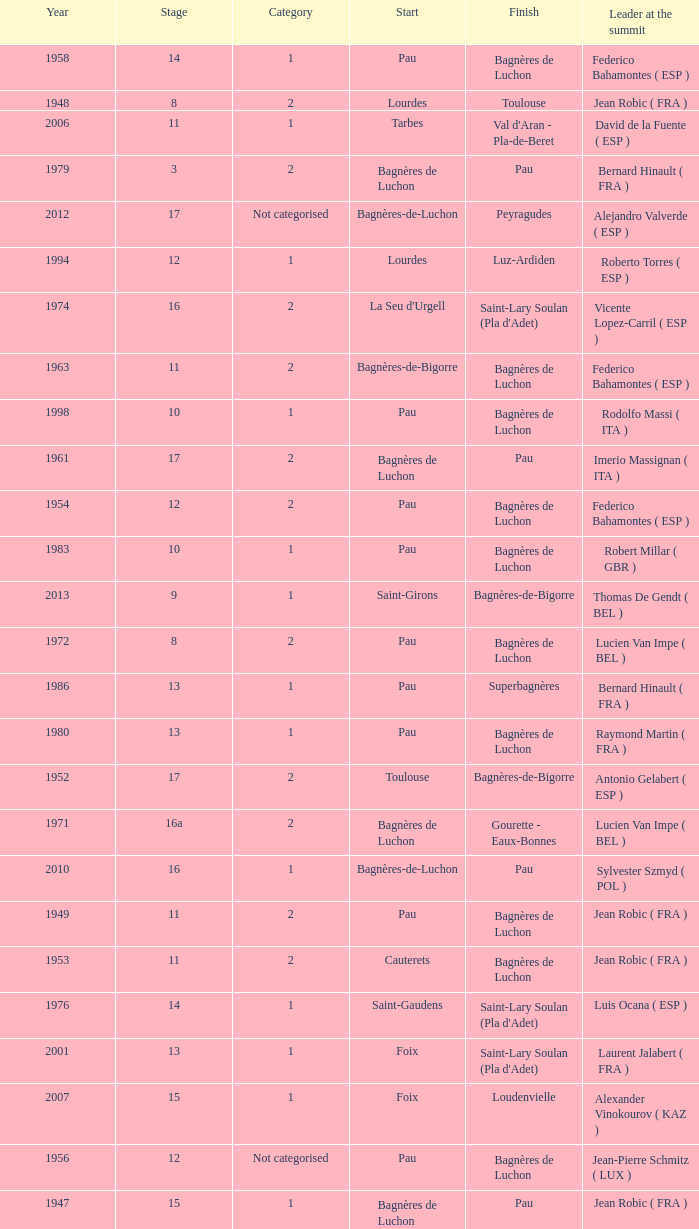What stage has a start of saint-girons in 1988? 15.0. Can you give me this table as a dict? {'header': ['Year', 'Stage', 'Category', 'Start', 'Finish', 'Leader at the summit'], 'rows': [['1958', '14', '1', 'Pau', 'Bagnères de Luchon', 'Federico Bahamontes ( ESP )'], ['1948', '8', '2', 'Lourdes', 'Toulouse', 'Jean Robic ( FRA )'], ['2006', '11', '1', 'Tarbes', "Val d'Aran - Pla-de-Beret", 'David de la Fuente ( ESP )'], ['1979', '3', '2', 'Bagnères de Luchon', 'Pau', 'Bernard Hinault ( FRA )'], ['2012', '17', 'Not categorised', 'Bagnères-de-Luchon', 'Peyragudes', 'Alejandro Valverde ( ESP )'], ['1994', '12', '1', 'Lourdes', 'Luz-Ardiden', 'Roberto Torres ( ESP )'], ['1974', '16', '2', "La Seu d'Urgell", "Saint-Lary Soulan (Pla d'Adet)", 'Vicente Lopez-Carril ( ESP )'], ['1963', '11', '2', 'Bagnères-de-Bigorre', 'Bagnères de Luchon', 'Federico Bahamontes ( ESP )'], ['1998', '10', '1', 'Pau', 'Bagnères de Luchon', 'Rodolfo Massi ( ITA )'], ['1961', '17', '2', 'Bagnères de Luchon', 'Pau', 'Imerio Massignan ( ITA )'], ['1954', '12', '2', 'Pau', 'Bagnères de Luchon', 'Federico Bahamontes ( ESP )'], ['1983', '10', '1', 'Pau', 'Bagnères de Luchon', 'Robert Millar ( GBR )'], ['2013', '9', '1', 'Saint-Girons', 'Bagnères-de-Bigorre', 'Thomas De Gendt ( BEL )'], ['1972', '8', '2', 'Pau', 'Bagnères de Luchon', 'Lucien Van Impe ( BEL )'], ['1986', '13', '1', 'Pau', 'Superbagnères', 'Bernard Hinault ( FRA )'], ['1980', '13', '1', 'Pau', 'Bagnères de Luchon', 'Raymond Martin ( FRA )'], ['1952', '17', '2', 'Toulouse', 'Bagnères-de-Bigorre', 'Antonio Gelabert ( ESP )'], ['1971', '16a', '2', 'Bagnères de Luchon', 'Gourette - Eaux-Bonnes', 'Lucien Van Impe ( BEL )'], ['2010', '16', '1', 'Bagnères-de-Luchon', 'Pau', 'Sylvester Szmyd ( POL )'], ['1949', '11', '2', 'Pau', 'Bagnères de Luchon', 'Jean Robic ( FRA )'], ['1953', '11', '2', 'Cauterets', 'Bagnères de Luchon', 'Jean Robic ( FRA )'], ['1976', '14', '1', 'Saint-Gaudens', "Saint-Lary Soulan (Pla d'Adet)", 'Luis Ocana ( ESP )'], ['2001', '13', '1', 'Foix', "Saint-Lary Soulan (Pla d'Adet)", 'Laurent Jalabert ( FRA )'], ['2007', '15', '1', 'Foix', 'Loudenvielle', 'Alexander Vinokourov ( KAZ )'], ['1956', '12', 'Not categorised', 'Pau', 'Bagnères de Luchon', 'Jean-Pierre Schmitz ( LUX )'], ['1947', '15', '1', 'Bagnères de Luchon', 'Pau', 'Jean Robic ( FRA )'], ['1969', '17', '2', 'La Mongie', 'Mourenx', 'Joaquim Galera ( ESP )'], ['2012', '16', '1', 'Pau', 'Bagnères-de-Luchon', 'Thomas Voeckler ( FRA )'], ['1951', '14', '2', 'Tarbes', 'Bagnères de Luchon', 'Fausto Coppi ( ITA )'], ['1962', '12', '2', 'Pau', 'Saint-Gaudens', 'Federico Bahamontes ( ESP )'], ['1964', '16', '2', 'Bagnères de Luchon', 'Pau', 'Julio Jiménez ( ESP )'], ['1999', '15', '1', 'Saint-Gaudens', 'Piau-Engaly', 'Alberto Elli ( ITA )'], ['1959', '11', '1', 'Bagnères-de-Bigorre', 'Saint-Gaudens', 'Valentin Huot ( FRA )'], ['1988', '15', '1', 'Saint-Girons', 'Luz-Ardiden', 'Steven Rooks ( NED )'], ['1981', '6', '1', 'Saint-Gaudens', "Saint-Lary Soulan (Pla d'Adet)", 'Bernard Hinault ( FRA )'], ['1993', '16', '1', 'Andorra', "Saint-Lary Soulan (Pla d'Adet)", 'Claudio Chiappucci ( ITA )'], ['1995', '15', '1', 'Saint-Girons', 'Cauterets - Crêtes du Lys', 'Richard Virenque ( FRA )'], ['1989', '10', '1', 'Cauterets', 'Superbagnères', 'Robert Millar ( GBR )'], ['2005', '15', '1', 'Lézat-sur-Lèze', "Saint-Lary Soulan (Pla d'Adet)", 'Laurent Brochard ( FRA )'], ['1955', '17', '2', 'Toulouse', 'Saint-Gaudens', 'Charly Gaul ( LUX )'], ['2008', '9', '1', 'Toulouse', 'Bagnères-de-Bigorre', 'Sebastian Lang ( DEU )'], ['2003', '14', '1', 'Saint-Girons', 'Loudenvielle', 'Gilberto Simoni ( ITA )'], ['1960', '11', '1', 'Pau', 'Bagnères de Luchon', 'Kurt Gimmi ( SUI )'], ['1970', '18', '2', 'Saint-Gaudens', 'La Mongie', 'Raymond Delisle ( FRA )']]} 